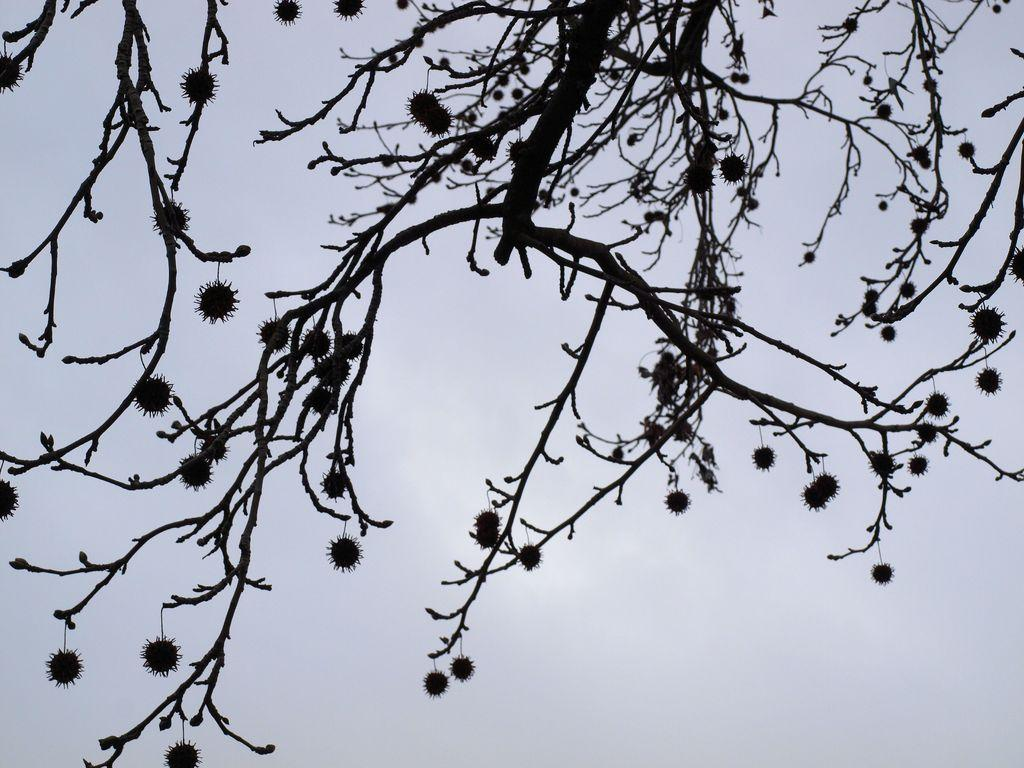What type of plant is present in the image? There is a tree with fruits in the image. What can be seen in the background of the image? The sky is visible in the background of the image. What type of pan is hanging from the tree in the image? There is no pan present in the image; it features a tree with fruits and a visible sky in the background. 